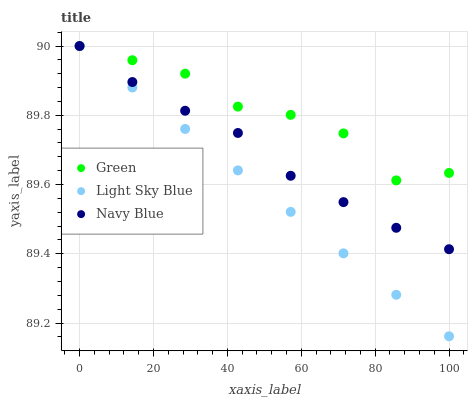Does Light Sky Blue have the minimum area under the curve?
Answer yes or no. Yes. Does Green have the maximum area under the curve?
Answer yes or no. Yes. Does Green have the minimum area under the curve?
Answer yes or no. No. Does Light Sky Blue have the maximum area under the curve?
Answer yes or no. No. Is Light Sky Blue the smoothest?
Answer yes or no. Yes. Is Green the roughest?
Answer yes or no. Yes. Is Green the smoothest?
Answer yes or no. No. Is Light Sky Blue the roughest?
Answer yes or no. No. Does Light Sky Blue have the lowest value?
Answer yes or no. Yes. Does Green have the lowest value?
Answer yes or no. No. Does Green have the highest value?
Answer yes or no. Yes. Does Navy Blue intersect Green?
Answer yes or no. Yes. Is Navy Blue less than Green?
Answer yes or no. No. Is Navy Blue greater than Green?
Answer yes or no. No. 